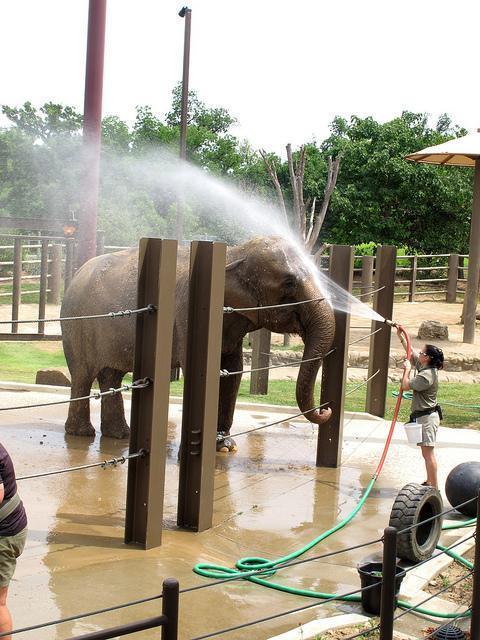How many water hose connected?
Give a very brief answer. 2. How many people are there?
Give a very brief answer. 2. 